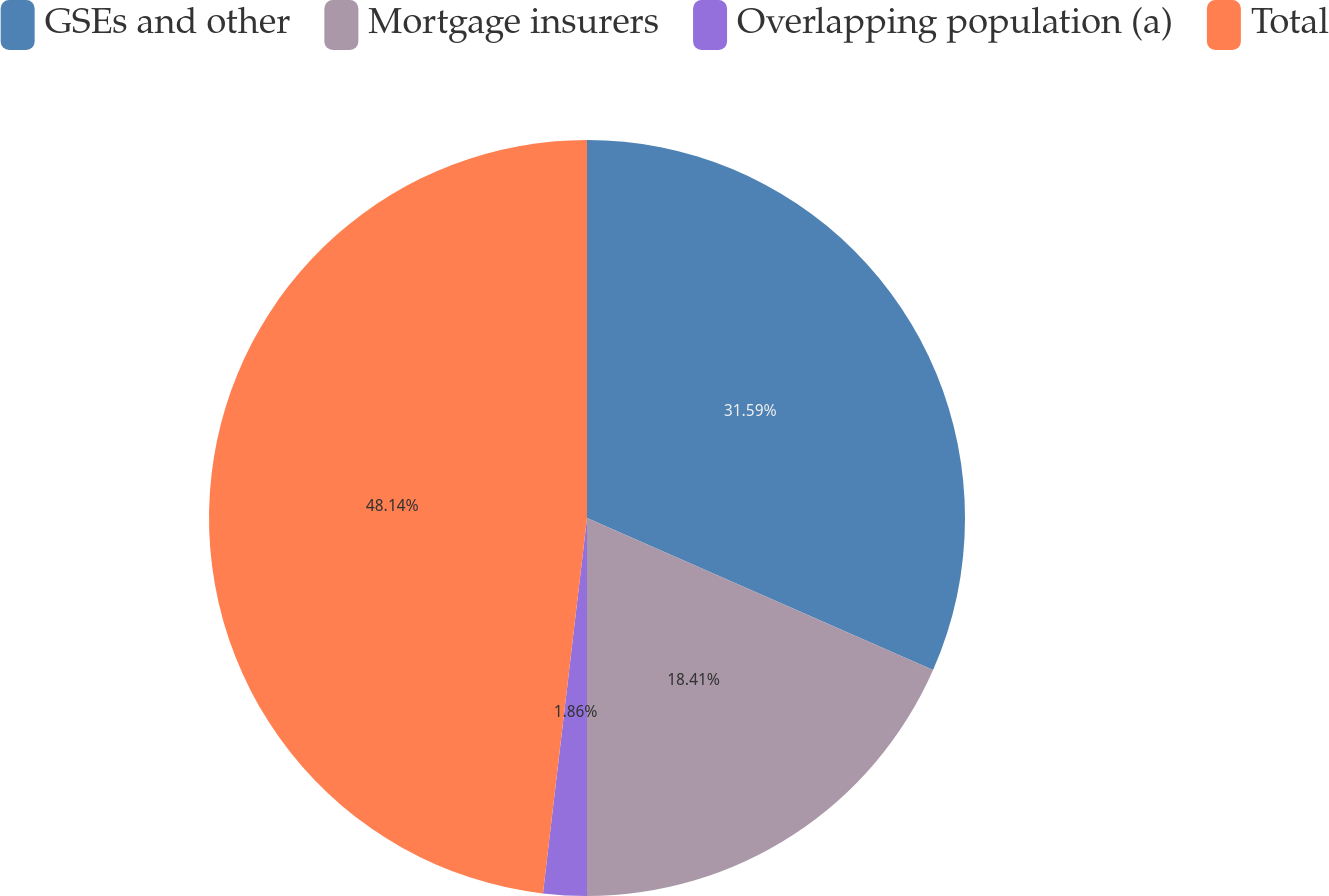<chart> <loc_0><loc_0><loc_500><loc_500><pie_chart><fcel>GSEs and other<fcel>Mortgage insurers<fcel>Overlapping population (a)<fcel>Total<nl><fcel>31.59%<fcel>18.41%<fcel>1.86%<fcel>48.14%<nl></chart> 